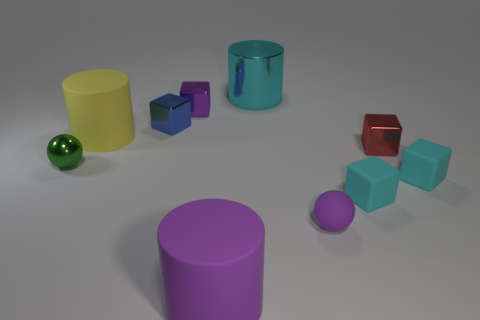Is the number of small cyan metallic balls greater than the number of large yellow rubber cylinders?
Provide a succinct answer. No. There is a tiny metallic object in front of the tiny red block; is its shape the same as the large cyan shiny object?
Your response must be concise. No. Is the number of blue rubber cylinders less than the number of cubes?
Your answer should be compact. Yes. There is a purple ball that is the same size as the green metallic object; what material is it?
Provide a succinct answer. Rubber. Does the metallic cylinder have the same color as the cube on the right side of the tiny red object?
Offer a very short reply. Yes. Are there fewer matte balls to the left of the large metallic cylinder than blue metallic cubes?
Your response must be concise. Yes. How many large blue rubber balls are there?
Your answer should be compact. 0. What is the shape of the object that is right of the small metal cube right of the tiny rubber ball?
Make the answer very short. Cube. There is a tiny purple rubber thing; what number of large matte cylinders are in front of it?
Give a very brief answer. 1. Do the large cyan object and the purple thing behind the small blue metallic cube have the same material?
Your answer should be compact. Yes. 